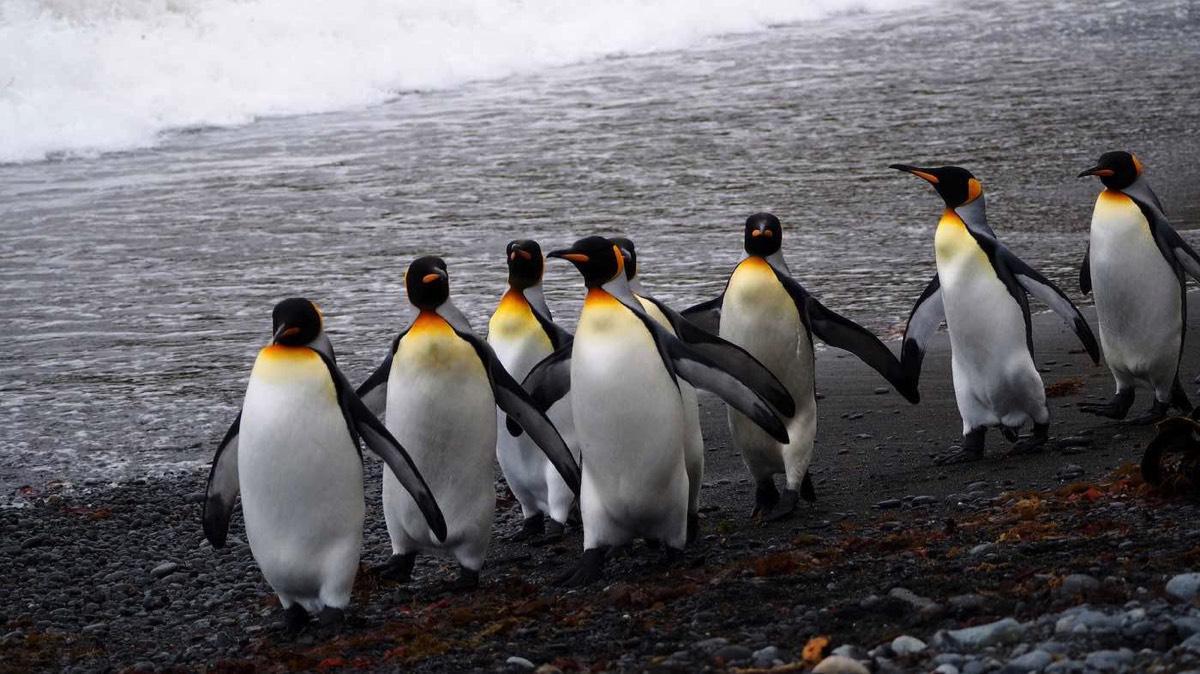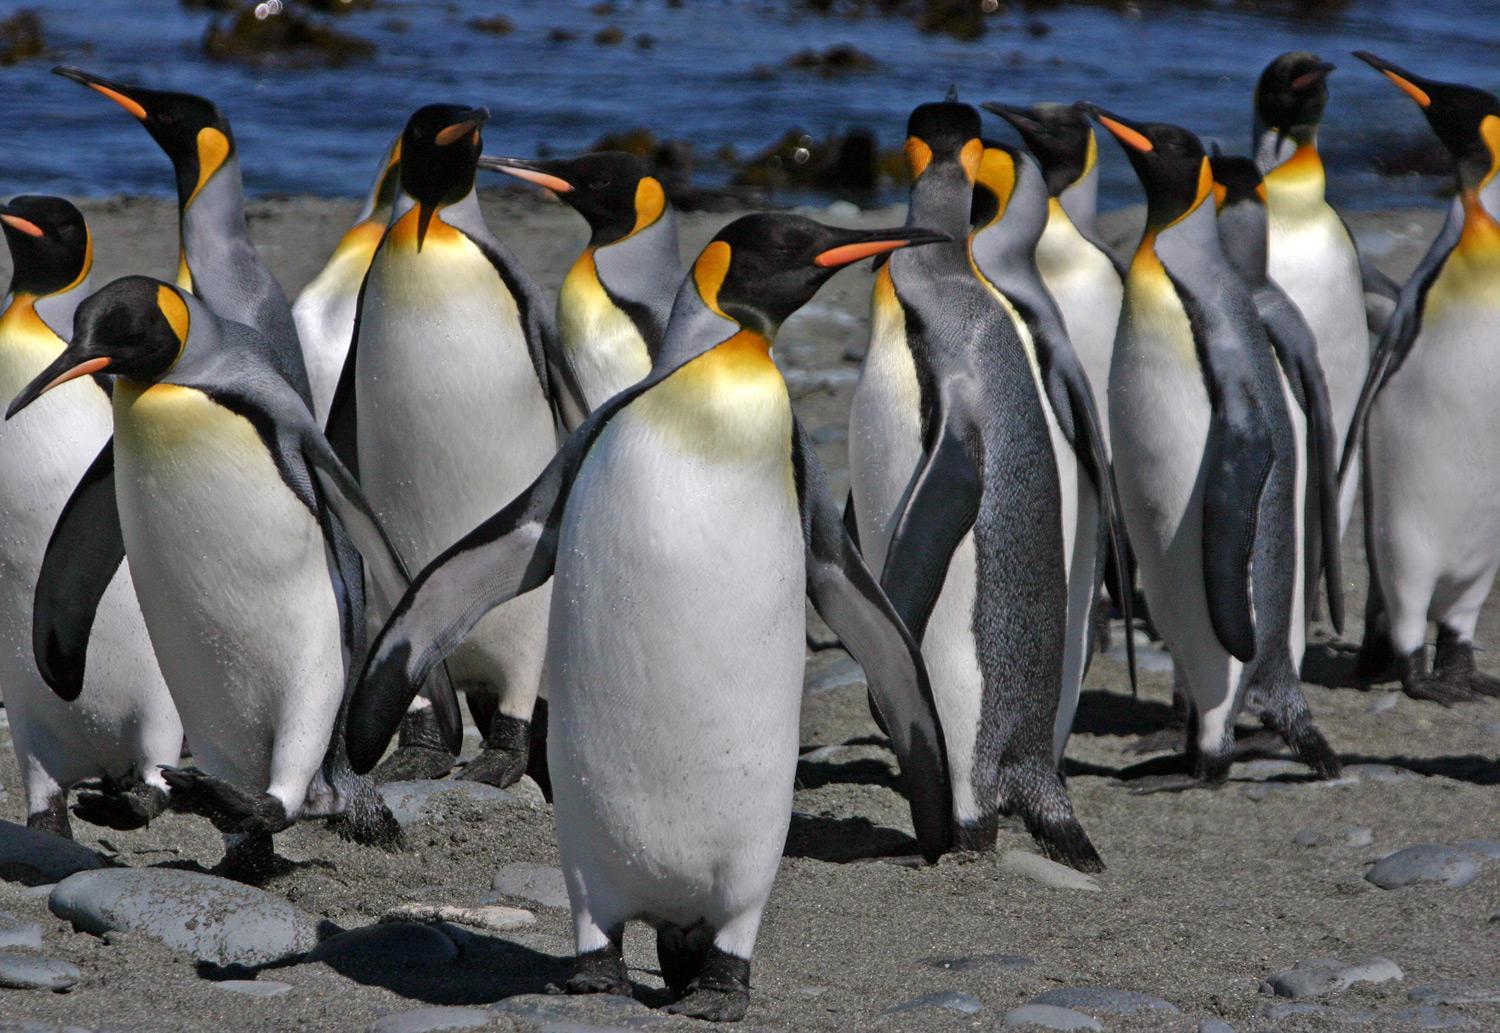The first image is the image on the left, the second image is the image on the right. Examine the images to the left and right. Is the description "Both images contain the same number of penguins in the foreground." accurate? Answer yes or no. No. 